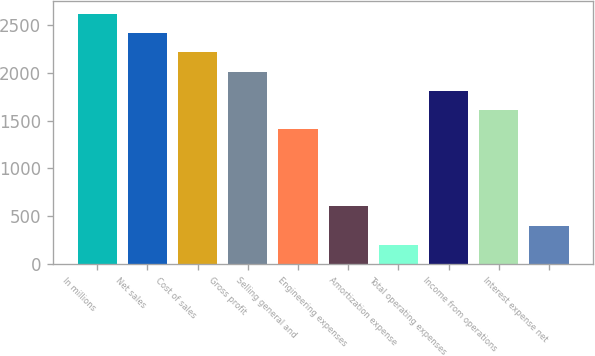Convert chart to OTSL. <chart><loc_0><loc_0><loc_500><loc_500><bar_chart><fcel>In millions<fcel>Net sales<fcel>Cost of sales<fcel>Gross profit<fcel>Selling general and<fcel>Engineering expenses<fcel>Amortization expense<fcel>Total operating expenses<fcel>Income from operations<fcel>Interest expense net<nl><fcel>2612.97<fcel>2411.98<fcel>2210.99<fcel>2010<fcel>1407.03<fcel>603.07<fcel>201.09<fcel>1809.01<fcel>1608.02<fcel>402.08<nl></chart> 